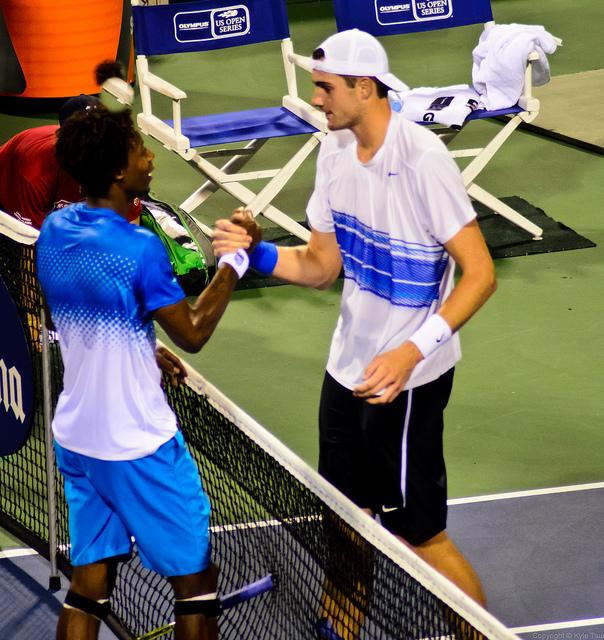Are the men arm-wrestling?
Keep it brief. No. Who is wearing a cap?
Quick response, please. Man on right. What are these men doing?
Give a very brief answer. Shaking hands. 